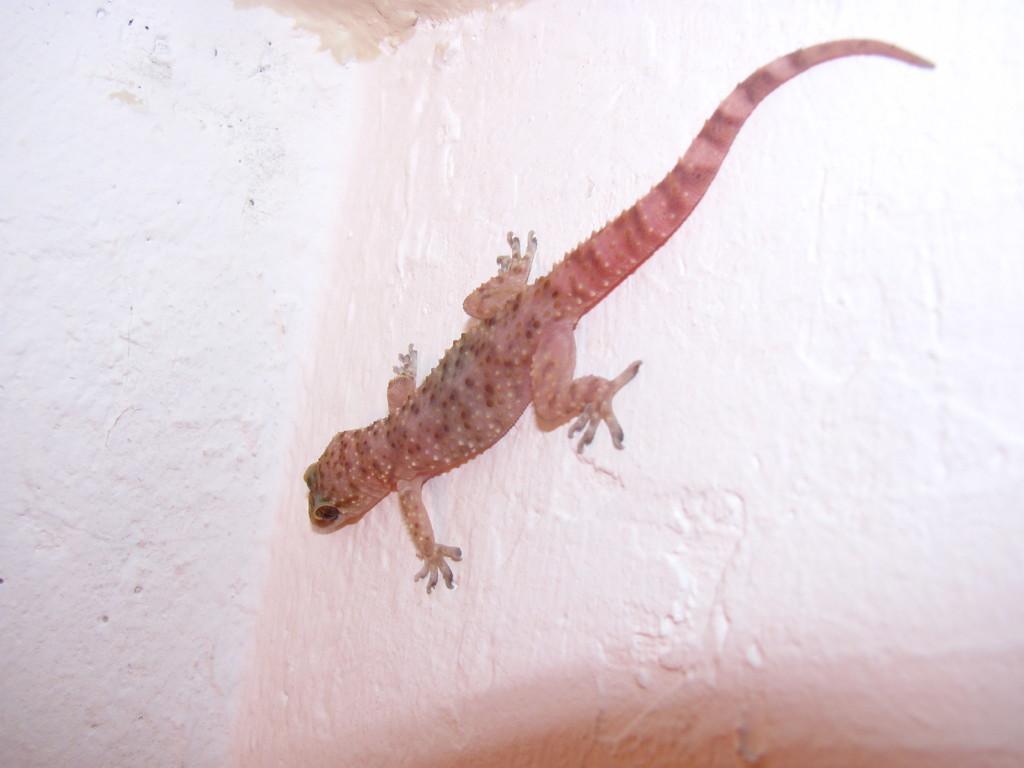Could you give a brief overview of what you see in this image? In this image we can see there is a lizard on the wall. 